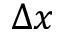Convert formula to latex. <formula><loc_0><loc_0><loc_500><loc_500>\Delta x</formula> 